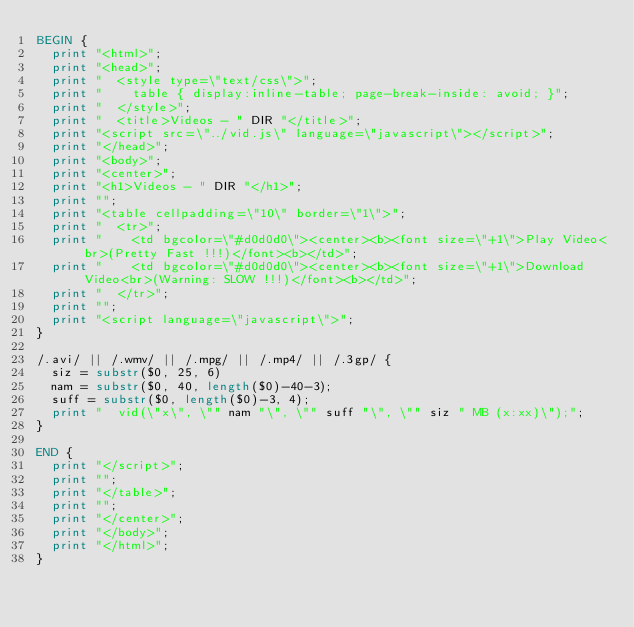<code> <loc_0><loc_0><loc_500><loc_500><_Awk_>BEGIN {
  print "<html>";
  print "<head>";
  print "  <style type=\"text/css\">";
  print "    table { display:inline-table; page-break-inside: avoid; }";
  print "  </style>";
  print "  <title>Videos - " DIR "</title>";
  print "<script src=\"../vid.js\" language=\"javascript\"></script>";
  print "</head>";
  print "<body>";
  print "<center>";
  print "<h1>Videos - " DIR "</h1>";
  print "";
  print "<table cellpadding=\"10\" border=\"1\">";
  print "  <tr>";
  print "    <td bgcolor=\"#d0d0d0\"><center><b><font size=\"+1\">Play Video<br>(Pretty Fast !!!)</font><b></td>";
  print "    <td bgcolor=\"#d0d0d0\"><center><b><font size=\"+1\">Download Video<br>(Warning: SLOW !!!)</font><b></td>";
  print "  </tr>";
  print "";
  print "<script language=\"javascript\">";
}

/.avi/ || /.wmv/ || /.mpg/ || /.mp4/ || /.3gp/ {
  siz = substr($0, 25, 6)
  nam = substr($0, 40, length($0)-40-3);
  suff = substr($0, length($0)-3, 4);
  print "  vid(\"x\", \"" nam "\", \"" suff "\", \"" siz " MB (x:xx)\");";
}

END {
  print "</script>";
  print "";
  print "</table>";
  print "";
  print "</center>";
  print "</body>";
  print "</html>";
}
</code> 